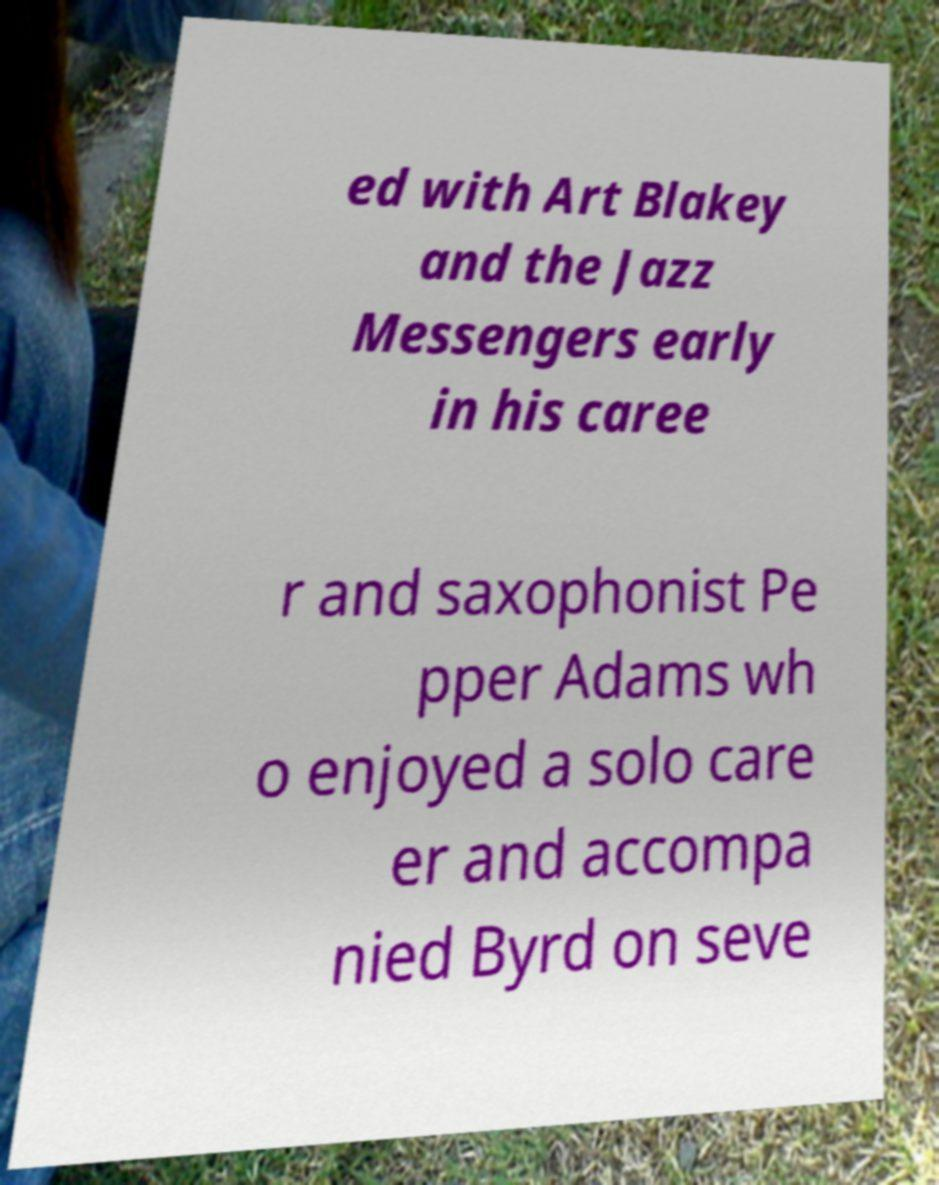There's text embedded in this image that I need extracted. Can you transcribe it verbatim? ed with Art Blakey and the Jazz Messengers early in his caree r and saxophonist Pe pper Adams wh o enjoyed a solo care er and accompa nied Byrd on seve 